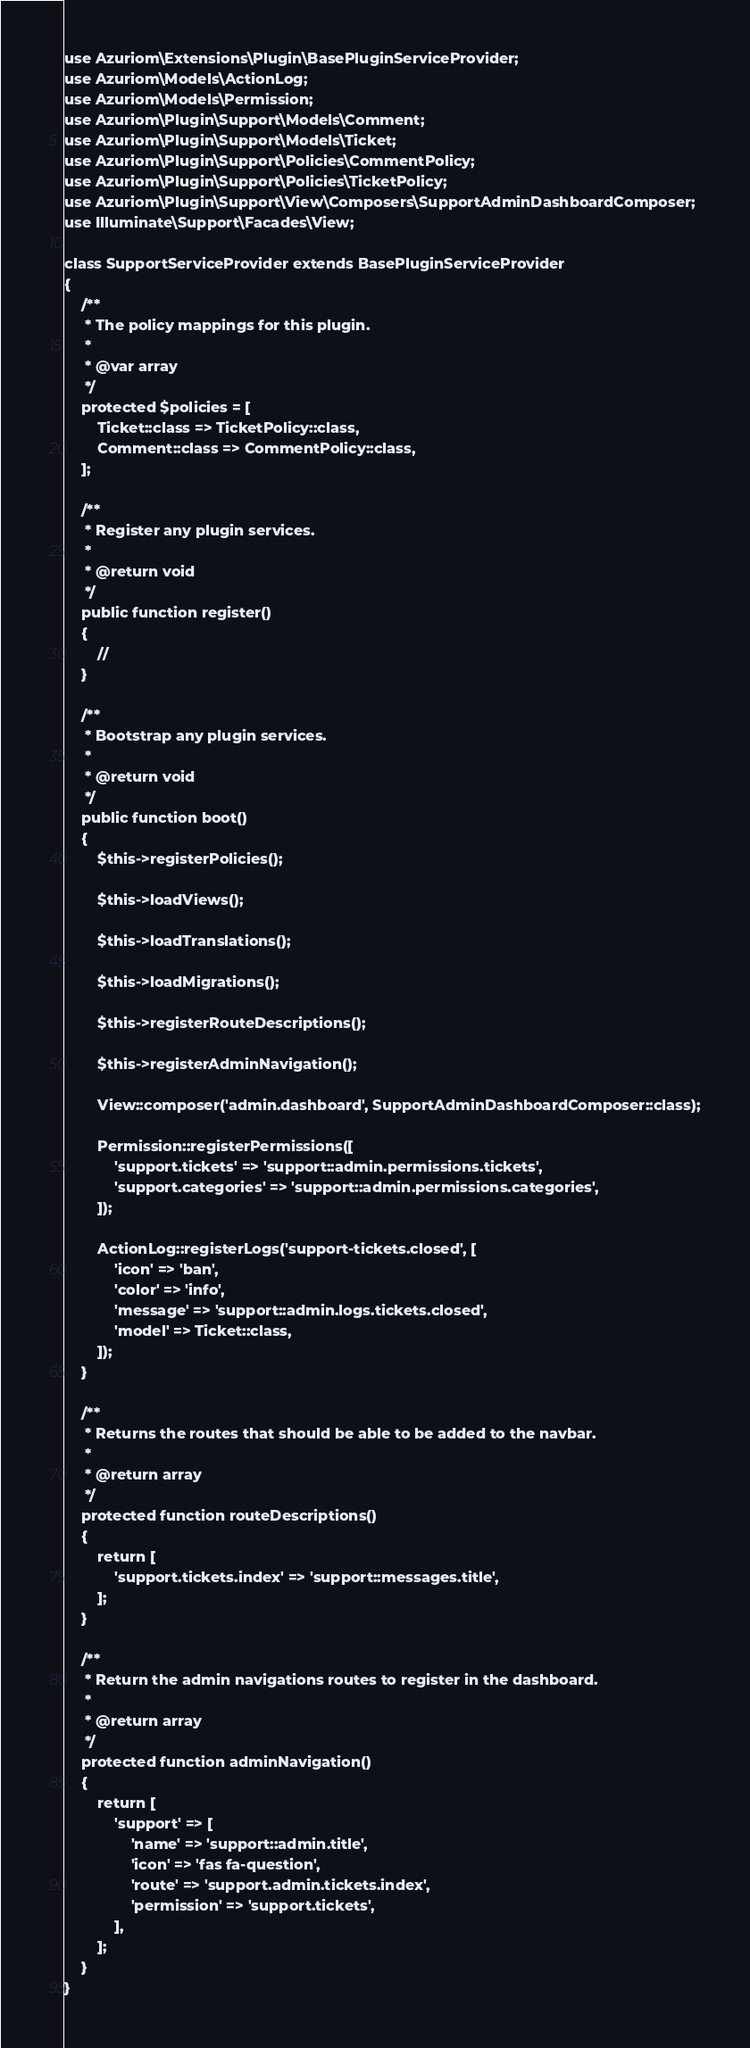Convert code to text. <code><loc_0><loc_0><loc_500><loc_500><_PHP_>use Azuriom\Extensions\Plugin\BasePluginServiceProvider;
use Azuriom\Models\ActionLog;
use Azuriom\Models\Permission;
use Azuriom\Plugin\Support\Models\Comment;
use Azuriom\Plugin\Support\Models\Ticket;
use Azuriom\Plugin\Support\Policies\CommentPolicy;
use Azuriom\Plugin\Support\Policies\TicketPolicy;
use Azuriom\Plugin\Support\View\Composers\SupportAdminDashboardComposer;
use Illuminate\Support\Facades\View;

class SupportServiceProvider extends BasePluginServiceProvider
{
    /**
     * The policy mappings for this plugin.
     *
     * @var array
     */
    protected $policies = [
        Ticket::class => TicketPolicy::class,
        Comment::class => CommentPolicy::class,
    ];

    /**
     * Register any plugin services.
     *
     * @return void
     */
    public function register()
    {
        //
    }

    /**
     * Bootstrap any plugin services.
     *
     * @return void
     */
    public function boot()
    {
        $this->registerPolicies();

        $this->loadViews();

        $this->loadTranslations();

        $this->loadMigrations();

        $this->registerRouteDescriptions();

        $this->registerAdminNavigation();

        View::composer('admin.dashboard', SupportAdminDashboardComposer::class);

        Permission::registerPermissions([
            'support.tickets' => 'support::admin.permissions.tickets',
            'support.categories' => 'support::admin.permissions.categories',
        ]);

        ActionLog::registerLogs('support-tickets.closed', [
            'icon' => 'ban',
            'color' => 'info',
            'message' => 'support::admin.logs.tickets.closed',
            'model' => Ticket::class,
        ]);
    }

    /**
     * Returns the routes that should be able to be added to the navbar.
     *
     * @return array
     */
    protected function routeDescriptions()
    {
        return [
            'support.tickets.index' => 'support::messages.title',
        ];
    }

    /**
     * Return the admin navigations routes to register in the dashboard.
     *
     * @return array
     */
    protected function adminNavigation()
    {
        return [
            'support' => [
                'name' => 'support::admin.title',
                'icon' => 'fas fa-question',
                'route' => 'support.admin.tickets.index',
                'permission' => 'support.tickets',
            ],
        ];
    }
}
</code> 